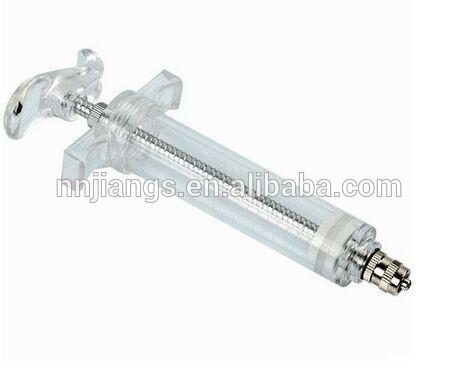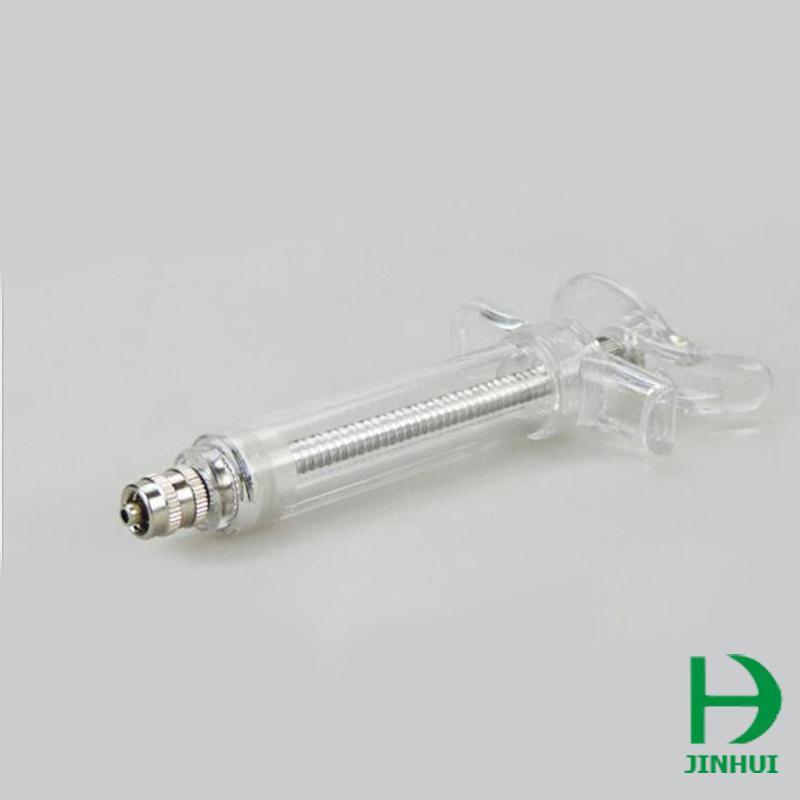The first image is the image on the left, the second image is the image on the right. Examine the images to the left and right. Is the description "There are two orange colored syringes." accurate? Answer yes or no. No. The first image is the image on the left, the second image is the image on the right. Examine the images to the left and right. Is the description "Each of the syringes has an orange plunger." accurate? Answer yes or no. No. 